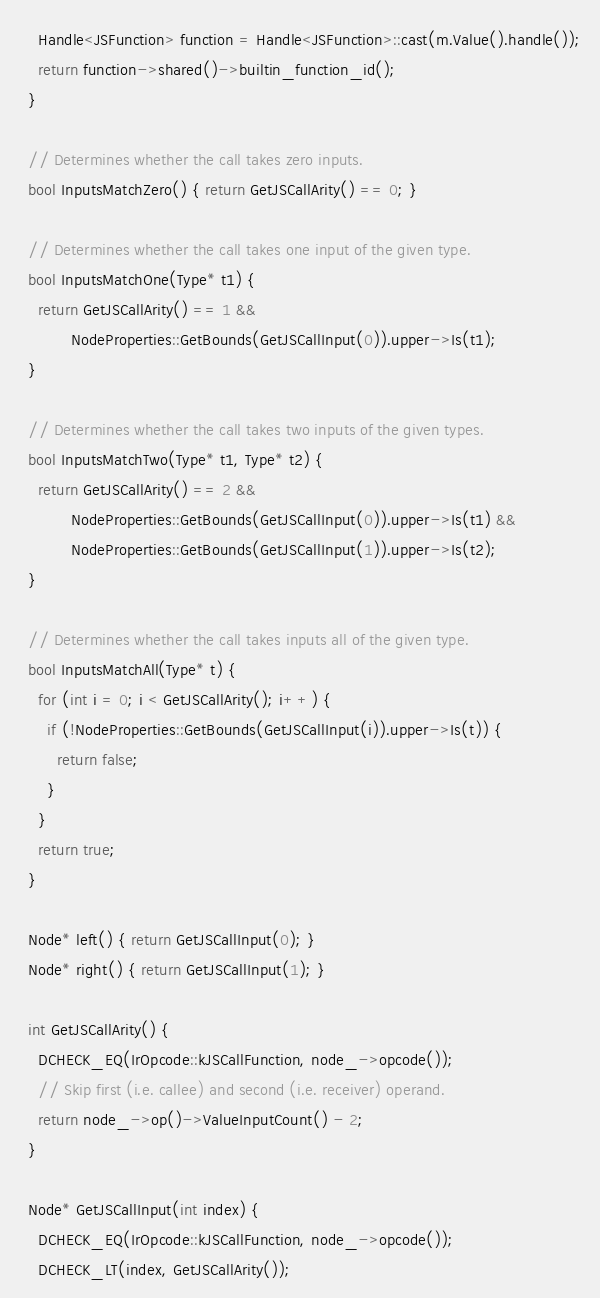Convert code to text. <code><loc_0><loc_0><loc_500><loc_500><_C++_>    Handle<JSFunction> function = Handle<JSFunction>::cast(m.Value().handle());
    return function->shared()->builtin_function_id();
  }

  // Determines whether the call takes zero inputs.
  bool InputsMatchZero() { return GetJSCallArity() == 0; }

  // Determines whether the call takes one input of the given type.
  bool InputsMatchOne(Type* t1) {
    return GetJSCallArity() == 1 &&
           NodeProperties::GetBounds(GetJSCallInput(0)).upper->Is(t1);
  }

  // Determines whether the call takes two inputs of the given types.
  bool InputsMatchTwo(Type* t1, Type* t2) {
    return GetJSCallArity() == 2 &&
           NodeProperties::GetBounds(GetJSCallInput(0)).upper->Is(t1) &&
           NodeProperties::GetBounds(GetJSCallInput(1)).upper->Is(t2);
  }

  // Determines whether the call takes inputs all of the given type.
  bool InputsMatchAll(Type* t) {
    for (int i = 0; i < GetJSCallArity(); i++) {
      if (!NodeProperties::GetBounds(GetJSCallInput(i)).upper->Is(t)) {
        return false;
      }
    }
    return true;
  }

  Node* left() { return GetJSCallInput(0); }
  Node* right() { return GetJSCallInput(1); }

  int GetJSCallArity() {
    DCHECK_EQ(IrOpcode::kJSCallFunction, node_->opcode());
    // Skip first (i.e. callee) and second (i.e. receiver) operand.
    return node_->op()->ValueInputCount() - 2;
  }

  Node* GetJSCallInput(int index) {
    DCHECK_EQ(IrOpcode::kJSCallFunction, node_->opcode());
    DCHECK_LT(index, GetJSCallArity());</code> 